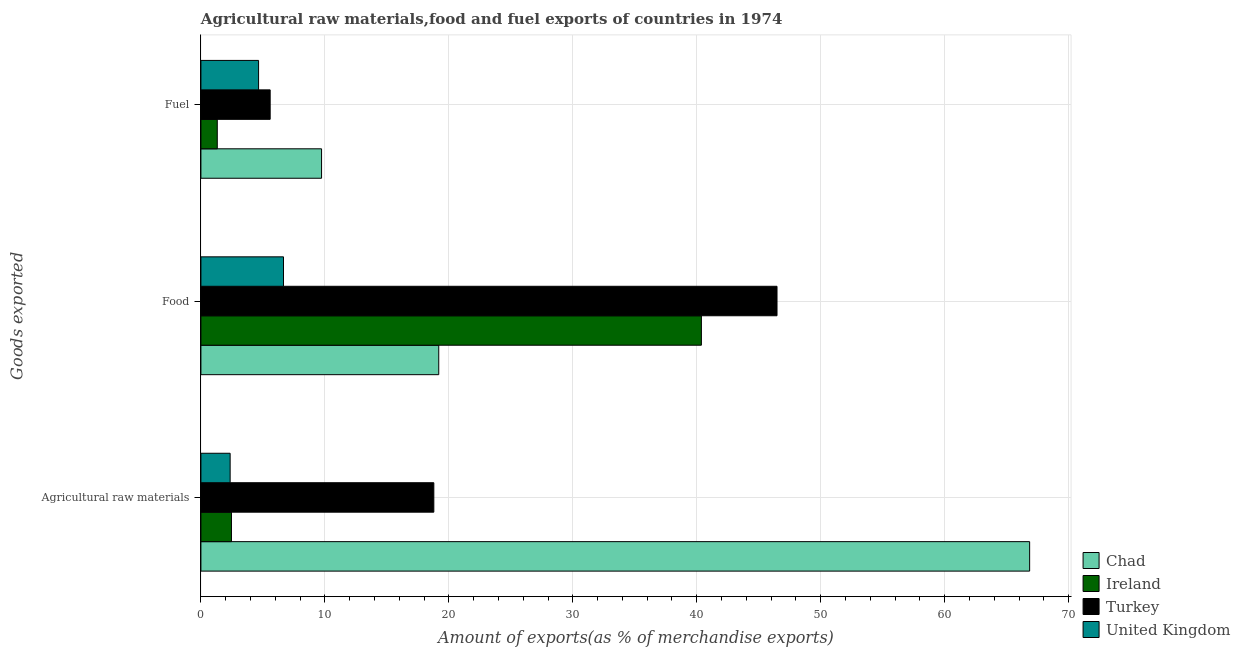How many different coloured bars are there?
Provide a short and direct response. 4. How many groups of bars are there?
Offer a terse response. 3. Are the number of bars on each tick of the Y-axis equal?
Your response must be concise. Yes. How many bars are there on the 3rd tick from the bottom?
Make the answer very short. 4. What is the label of the 3rd group of bars from the top?
Provide a succinct answer. Agricultural raw materials. What is the percentage of food exports in Chad?
Your response must be concise. 19.19. Across all countries, what is the maximum percentage of fuel exports?
Provide a succinct answer. 9.73. Across all countries, what is the minimum percentage of food exports?
Your answer should be compact. 6.66. In which country was the percentage of raw materials exports maximum?
Make the answer very short. Chad. In which country was the percentage of food exports minimum?
Your answer should be compact. United Kingdom. What is the total percentage of food exports in the graph?
Your response must be concise. 112.69. What is the difference between the percentage of raw materials exports in United Kingdom and that in Chad?
Provide a succinct answer. -64.49. What is the difference between the percentage of food exports in Ireland and the percentage of raw materials exports in United Kingdom?
Provide a short and direct response. 38.01. What is the average percentage of fuel exports per country?
Provide a short and direct response. 5.32. What is the difference between the percentage of raw materials exports and percentage of fuel exports in United Kingdom?
Your response must be concise. -2.29. What is the ratio of the percentage of raw materials exports in Chad to that in Turkey?
Offer a very short reply. 3.56. Is the percentage of fuel exports in Ireland less than that in United Kingdom?
Your answer should be very brief. Yes. What is the difference between the highest and the second highest percentage of fuel exports?
Keep it short and to the point. 4.15. What is the difference between the highest and the lowest percentage of fuel exports?
Your answer should be compact. 8.41. Is the sum of the percentage of food exports in Chad and Turkey greater than the maximum percentage of fuel exports across all countries?
Offer a very short reply. Yes. What does the 3rd bar from the top in Agricultural raw materials represents?
Ensure brevity in your answer.  Ireland. Is it the case that in every country, the sum of the percentage of raw materials exports and percentage of food exports is greater than the percentage of fuel exports?
Give a very brief answer. Yes. How many countries are there in the graph?
Provide a short and direct response. 4. What is the difference between two consecutive major ticks on the X-axis?
Ensure brevity in your answer.  10. Are the values on the major ticks of X-axis written in scientific E-notation?
Keep it short and to the point. No. Does the graph contain any zero values?
Give a very brief answer. No. Where does the legend appear in the graph?
Offer a terse response. Bottom right. How many legend labels are there?
Provide a succinct answer. 4. What is the title of the graph?
Provide a succinct answer. Agricultural raw materials,food and fuel exports of countries in 1974. What is the label or title of the X-axis?
Offer a terse response. Amount of exports(as % of merchandise exports). What is the label or title of the Y-axis?
Offer a terse response. Goods exported. What is the Amount of exports(as % of merchandise exports) of Chad in Agricultural raw materials?
Your answer should be compact. 66.85. What is the Amount of exports(as % of merchandise exports) of Ireland in Agricultural raw materials?
Provide a short and direct response. 2.46. What is the Amount of exports(as % of merchandise exports) in Turkey in Agricultural raw materials?
Give a very brief answer. 18.79. What is the Amount of exports(as % of merchandise exports) in United Kingdom in Agricultural raw materials?
Keep it short and to the point. 2.36. What is the Amount of exports(as % of merchandise exports) of Chad in Food?
Provide a succinct answer. 19.19. What is the Amount of exports(as % of merchandise exports) in Ireland in Food?
Your answer should be compact. 40.37. What is the Amount of exports(as % of merchandise exports) in Turkey in Food?
Your answer should be compact. 46.47. What is the Amount of exports(as % of merchandise exports) in United Kingdom in Food?
Ensure brevity in your answer.  6.66. What is the Amount of exports(as % of merchandise exports) of Chad in Fuel?
Your answer should be compact. 9.73. What is the Amount of exports(as % of merchandise exports) in Ireland in Fuel?
Ensure brevity in your answer.  1.32. What is the Amount of exports(as % of merchandise exports) in Turkey in Fuel?
Your answer should be very brief. 5.59. What is the Amount of exports(as % of merchandise exports) of United Kingdom in Fuel?
Provide a succinct answer. 4.65. Across all Goods exported, what is the maximum Amount of exports(as % of merchandise exports) of Chad?
Your answer should be compact. 66.85. Across all Goods exported, what is the maximum Amount of exports(as % of merchandise exports) of Ireland?
Offer a very short reply. 40.37. Across all Goods exported, what is the maximum Amount of exports(as % of merchandise exports) of Turkey?
Your answer should be compact. 46.47. Across all Goods exported, what is the maximum Amount of exports(as % of merchandise exports) in United Kingdom?
Provide a succinct answer. 6.66. Across all Goods exported, what is the minimum Amount of exports(as % of merchandise exports) of Chad?
Your answer should be very brief. 9.73. Across all Goods exported, what is the minimum Amount of exports(as % of merchandise exports) in Ireland?
Your answer should be very brief. 1.32. Across all Goods exported, what is the minimum Amount of exports(as % of merchandise exports) of Turkey?
Your answer should be compact. 5.59. Across all Goods exported, what is the minimum Amount of exports(as % of merchandise exports) of United Kingdom?
Your answer should be compact. 2.36. What is the total Amount of exports(as % of merchandise exports) of Chad in the graph?
Provide a succinct answer. 95.77. What is the total Amount of exports(as % of merchandise exports) of Ireland in the graph?
Ensure brevity in your answer.  44.16. What is the total Amount of exports(as % of merchandise exports) of Turkey in the graph?
Offer a very short reply. 70.85. What is the total Amount of exports(as % of merchandise exports) of United Kingdom in the graph?
Keep it short and to the point. 13.67. What is the difference between the Amount of exports(as % of merchandise exports) of Chad in Agricultural raw materials and that in Food?
Make the answer very short. 47.66. What is the difference between the Amount of exports(as % of merchandise exports) of Ireland in Agricultural raw materials and that in Food?
Make the answer very short. -37.91. What is the difference between the Amount of exports(as % of merchandise exports) of Turkey in Agricultural raw materials and that in Food?
Make the answer very short. -27.68. What is the difference between the Amount of exports(as % of merchandise exports) of United Kingdom in Agricultural raw materials and that in Food?
Provide a succinct answer. -4.3. What is the difference between the Amount of exports(as % of merchandise exports) in Chad in Agricultural raw materials and that in Fuel?
Provide a short and direct response. 57.12. What is the difference between the Amount of exports(as % of merchandise exports) in Ireland in Agricultural raw materials and that in Fuel?
Ensure brevity in your answer.  1.14. What is the difference between the Amount of exports(as % of merchandise exports) in Turkey in Agricultural raw materials and that in Fuel?
Ensure brevity in your answer.  13.2. What is the difference between the Amount of exports(as % of merchandise exports) in United Kingdom in Agricultural raw materials and that in Fuel?
Provide a succinct answer. -2.29. What is the difference between the Amount of exports(as % of merchandise exports) of Chad in Food and that in Fuel?
Ensure brevity in your answer.  9.45. What is the difference between the Amount of exports(as % of merchandise exports) in Ireland in Food and that in Fuel?
Offer a terse response. 39.05. What is the difference between the Amount of exports(as % of merchandise exports) in Turkey in Food and that in Fuel?
Make the answer very short. 40.89. What is the difference between the Amount of exports(as % of merchandise exports) of United Kingdom in Food and that in Fuel?
Provide a short and direct response. 2.01. What is the difference between the Amount of exports(as % of merchandise exports) in Chad in Agricultural raw materials and the Amount of exports(as % of merchandise exports) in Ireland in Food?
Your answer should be very brief. 26.48. What is the difference between the Amount of exports(as % of merchandise exports) in Chad in Agricultural raw materials and the Amount of exports(as % of merchandise exports) in Turkey in Food?
Offer a terse response. 20.38. What is the difference between the Amount of exports(as % of merchandise exports) of Chad in Agricultural raw materials and the Amount of exports(as % of merchandise exports) of United Kingdom in Food?
Your response must be concise. 60.19. What is the difference between the Amount of exports(as % of merchandise exports) in Ireland in Agricultural raw materials and the Amount of exports(as % of merchandise exports) in Turkey in Food?
Make the answer very short. -44.01. What is the difference between the Amount of exports(as % of merchandise exports) of Ireland in Agricultural raw materials and the Amount of exports(as % of merchandise exports) of United Kingdom in Food?
Offer a terse response. -4.2. What is the difference between the Amount of exports(as % of merchandise exports) of Turkey in Agricultural raw materials and the Amount of exports(as % of merchandise exports) of United Kingdom in Food?
Your answer should be compact. 12.13. What is the difference between the Amount of exports(as % of merchandise exports) in Chad in Agricultural raw materials and the Amount of exports(as % of merchandise exports) in Ireland in Fuel?
Your response must be concise. 65.53. What is the difference between the Amount of exports(as % of merchandise exports) in Chad in Agricultural raw materials and the Amount of exports(as % of merchandise exports) in Turkey in Fuel?
Keep it short and to the point. 61.26. What is the difference between the Amount of exports(as % of merchandise exports) of Chad in Agricultural raw materials and the Amount of exports(as % of merchandise exports) of United Kingdom in Fuel?
Keep it short and to the point. 62.2. What is the difference between the Amount of exports(as % of merchandise exports) in Ireland in Agricultural raw materials and the Amount of exports(as % of merchandise exports) in Turkey in Fuel?
Provide a short and direct response. -3.12. What is the difference between the Amount of exports(as % of merchandise exports) of Ireland in Agricultural raw materials and the Amount of exports(as % of merchandise exports) of United Kingdom in Fuel?
Ensure brevity in your answer.  -2.19. What is the difference between the Amount of exports(as % of merchandise exports) in Turkey in Agricultural raw materials and the Amount of exports(as % of merchandise exports) in United Kingdom in Fuel?
Offer a very short reply. 14.14. What is the difference between the Amount of exports(as % of merchandise exports) of Chad in Food and the Amount of exports(as % of merchandise exports) of Ireland in Fuel?
Make the answer very short. 17.87. What is the difference between the Amount of exports(as % of merchandise exports) of Chad in Food and the Amount of exports(as % of merchandise exports) of Turkey in Fuel?
Offer a very short reply. 13.6. What is the difference between the Amount of exports(as % of merchandise exports) in Chad in Food and the Amount of exports(as % of merchandise exports) in United Kingdom in Fuel?
Give a very brief answer. 14.53. What is the difference between the Amount of exports(as % of merchandise exports) of Ireland in Food and the Amount of exports(as % of merchandise exports) of Turkey in Fuel?
Offer a terse response. 34.79. What is the difference between the Amount of exports(as % of merchandise exports) in Ireland in Food and the Amount of exports(as % of merchandise exports) in United Kingdom in Fuel?
Give a very brief answer. 35.72. What is the difference between the Amount of exports(as % of merchandise exports) of Turkey in Food and the Amount of exports(as % of merchandise exports) of United Kingdom in Fuel?
Provide a succinct answer. 41.82. What is the average Amount of exports(as % of merchandise exports) in Chad per Goods exported?
Your response must be concise. 31.92. What is the average Amount of exports(as % of merchandise exports) of Ireland per Goods exported?
Make the answer very short. 14.72. What is the average Amount of exports(as % of merchandise exports) in Turkey per Goods exported?
Ensure brevity in your answer.  23.62. What is the average Amount of exports(as % of merchandise exports) of United Kingdom per Goods exported?
Give a very brief answer. 4.56. What is the difference between the Amount of exports(as % of merchandise exports) of Chad and Amount of exports(as % of merchandise exports) of Ireland in Agricultural raw materials?
Your answer should be compact. 64.39. What is the difference between the Amount of exports(as % of merchandise exports) in Chad and Amount of exports(as % of merchandise exports) in Turkey in Agricultural raw materials?
Provide a short and direct response. 48.06. What is the difference between the Amount of exports(as % of merchandise exports) of Chad and Amount of exports(as % of merchandise exports) of United Kingdom in Agricultural raw materials?
Keep it short and to the point. 64.49. What is the difference between the Amount of exports(as % of merchandise exports) in Ireland and Amount of exports(as % of merchandise exports) in Turkey in Agricultural raw materials?
Offer a very short reply. -16.33. What is the difference between the Amount of exports(as % of merchandise exports) of Ireland and Amount of exports(as % of merchandise exports) of United Kingdom in Agricultural raw materials?
Your response must be concise. 0.11. What is the difference between the Amount of exports(as % of merchandise exports) in Turkey and Amount of exports(as % of merchandise exports) in United Kingdom in Agricultural raw materials?
Your answer should be very brief. 16.43. What is the difference between the Amount of exports(as % of merchandise exports) of Chad and Amount of exports(as % of merchandise exports) of Ireland in Food?
Provide a short and direct response. -21.19. What is the difference between the Amount of exports(as % of merchandise exports) in Chad and Amount of exports(as % of merchandise exports) in Turkey in Food?
Make the answer very short. -27.29. What is the difference between the Amount of exports(as % of merchandise exports) in Chad and Amount of exports(as % of merchandise exports) in United Kingdom in Food?
Your response must be concise. 12.52. What is the difference between the Amount of exports(as % of merchandise exports) of Ireland and Amount of exports(as % of merchandise exports) of Turkey in Food?
Ensure brevity in your answer.  -6.1. What is the difference between the Amount of exports(as % of merchandise exports) of Ireland and Amount of exports(as % of merchandise exports) of United Kingdom in Food?
Offer a terse response. 33.71. What is the difference between the Amount of exports(as % of merchandise exports) in Turkey and Amount of exports(as % of merchandise exports) in United Kingdom in Food?
Make the answer very short. 39.81. What is the difference between the Amount of exports(as % of merchandise exports) of Chad and Amount of exports(as % of merchandise exports) of Ireland in Fuel?
Keep it short and to the point. 8.41. What is the difference between the Amount of exports(as % of merchandise exports) of Chad and Amount of exports(as % of merchandise exports) of Turkey in Fuel?
Ensure brevity in your answer.  4.15. What is the difference between the Amount of exports(as % of merchandise exports) in Chad and Amount of exports(as % of merchandise exports) in United Kingdom in Fuel?
Provide a succinct answer. 5.08. What is the difference between the Amount of exports(as % of merchandise exports) of Ireland and Amount of exports(as % of merchandise exports) of Turkey in Fuel?
Make the answer very short. -4.27. What is the difference between the Amount of exports(as % of merchandise exports) in Ireland and Amount of exports(as % of merchandise exports) in United Kingdom in Fuel?
Your response must be concise. -3.33. What is the difference between the Amount of exports(as % of merchandise exports) of Turkey and Amount of exports(as % of merchandise exports) of United Kingdom in Fuel?
Give a very brief answer. 0.93. What is the ratio of the Amount of exports(as % of merchandise exports) of Chad in Agricultural raw materials to that in Food?
Offer a terse response. 3.48. What is the ratio of the Amount of exports(as % of merchandise exports) in Ireland in Agricultural raw materials to that in Food?
Provide a succinct answer. 0.06. What is the ratio of the Amount of exports(as % of merchandise exports) in Turkey in Agricultural raw materials to that in Food?
Provide a succinct answer. 0.4. What is the ratio of the Amount of exports(as % of merchandise exports) in United Kingdom in Agricultural raw materials to that in Food?
Provide a short and direct response. 0.35. What is the ratio of the Amount of exports(as % of merchandise exports) of Chad in Agricultural raw materials to that in Fuel?
Ensure brevity in your answer.  6.87. What is the ratio of the Amount of exports(as % of merchandise exports) of Ireland in Agricultural raw materials to that in Fuel?
Offer a terse response. 1.87. What is the ratio of the Amount of exports(as % of merchandise exports) of Turkey in Agricultural raw materials to that in Fuel?
Ensure brevity in your answer.  3.36. What is the ratio of the Amount of exports(as % of merchandise exports) in United Kingdom in Agricultural raw materials to that in Fuel?
Make the answer very short. 0.51. What is the ratio of the Amount of exports(as % of merchandise exports) in Chad in Food to that in Fuel?
Provide a succinct answer. 1.97. What is the ratio of the Amount of exports(as % of merchandise exports) of Ireland in Food to that in Fuel?
Provide a succinct answer. 30.58. What is the ratio of the Amount of exports(as % of merchandise exports) in Turkey in Food to that in Fuel?
Keep it short and to the point. 8.32. What is the ratio of the Amount of exports(as % of merchandise exports) in United Kingdom in Food to that in Fuel?
Offer a very short reply. 1.43. What is the difference between the highest and the second highest Amount of exports(as % of merchandise exports) in Chad?
Your response must be concise. 47.66. What is the difference between the highest and the second highest Amount of exports(as % of merchandise exports) of Ireland?
Offer a terse response. 37.91. What is the difference between the highest and the second highest Amount of exports(as % of merchandise exports) of Turkey?
Your response must be concise. 27.68. What is the difference between the highest and the second highest Amount of exports(as % of merchandise exports) in United Kingdom?
Your answer should be very brief. 2.01. What is the difference between the highest and the lowest Amount of exports(as % of merchandise exports) in Chad?
Ensure brevity in your answer.  57.12. What is the difference between the highest and the lowest Amount of exports(as % of merchandise exports) in Ireland?
Your response must be concise. 39.05. What is the difference between the highest and the lowest Amount of exports(as % of merchandise exports) in Turkey?
Make the answer very short. 40.89. What is the difference between the highest and the lowest Amount of exports(as % of merchandise exports) of United Kingdom?
Keep it short and to the point. 4.3. 